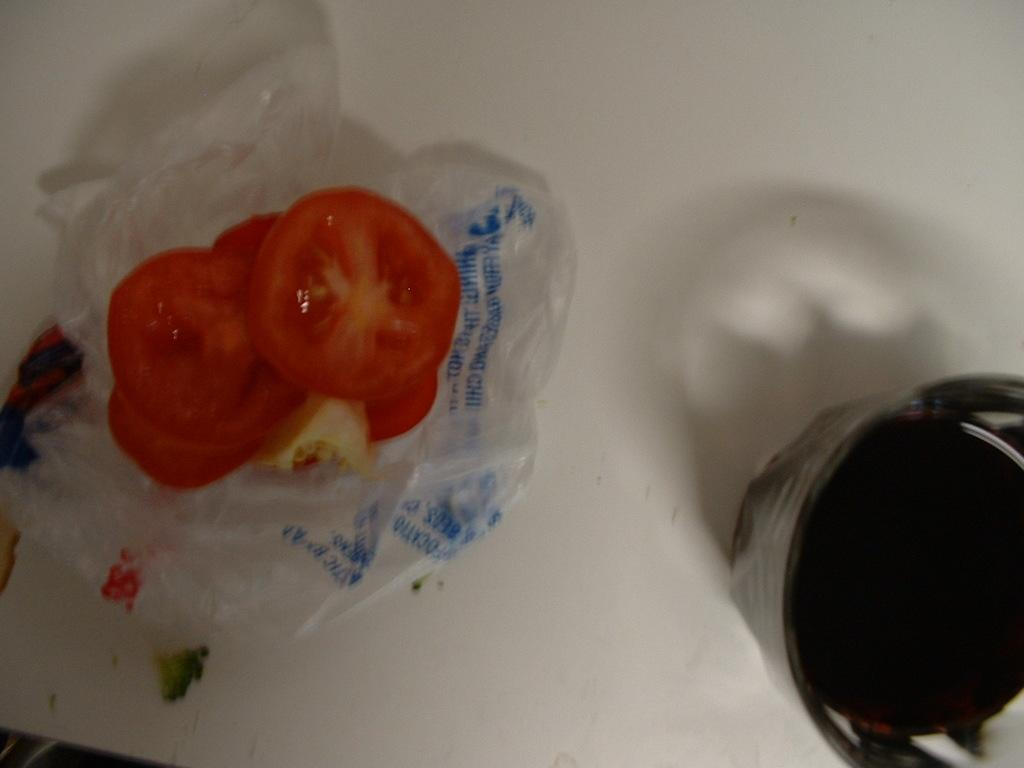What type of food is visible in the image? There are sliced tomatoes in the image. How are the sliced tomatoes arranged or placed? The sliced tomatoes are placed on a plastic cover. What else can be seen in the image besides the tomatoes? There is a glass of drink in the image. Where is the glass of drink located in the image? The glass of drink is in the right corner of the image. What type of duck can be seen swimming in the glass of drink? There is no duck present in the image; it only features sliced tomatoes on a plastic cover and a glass of drink in the right corner. 